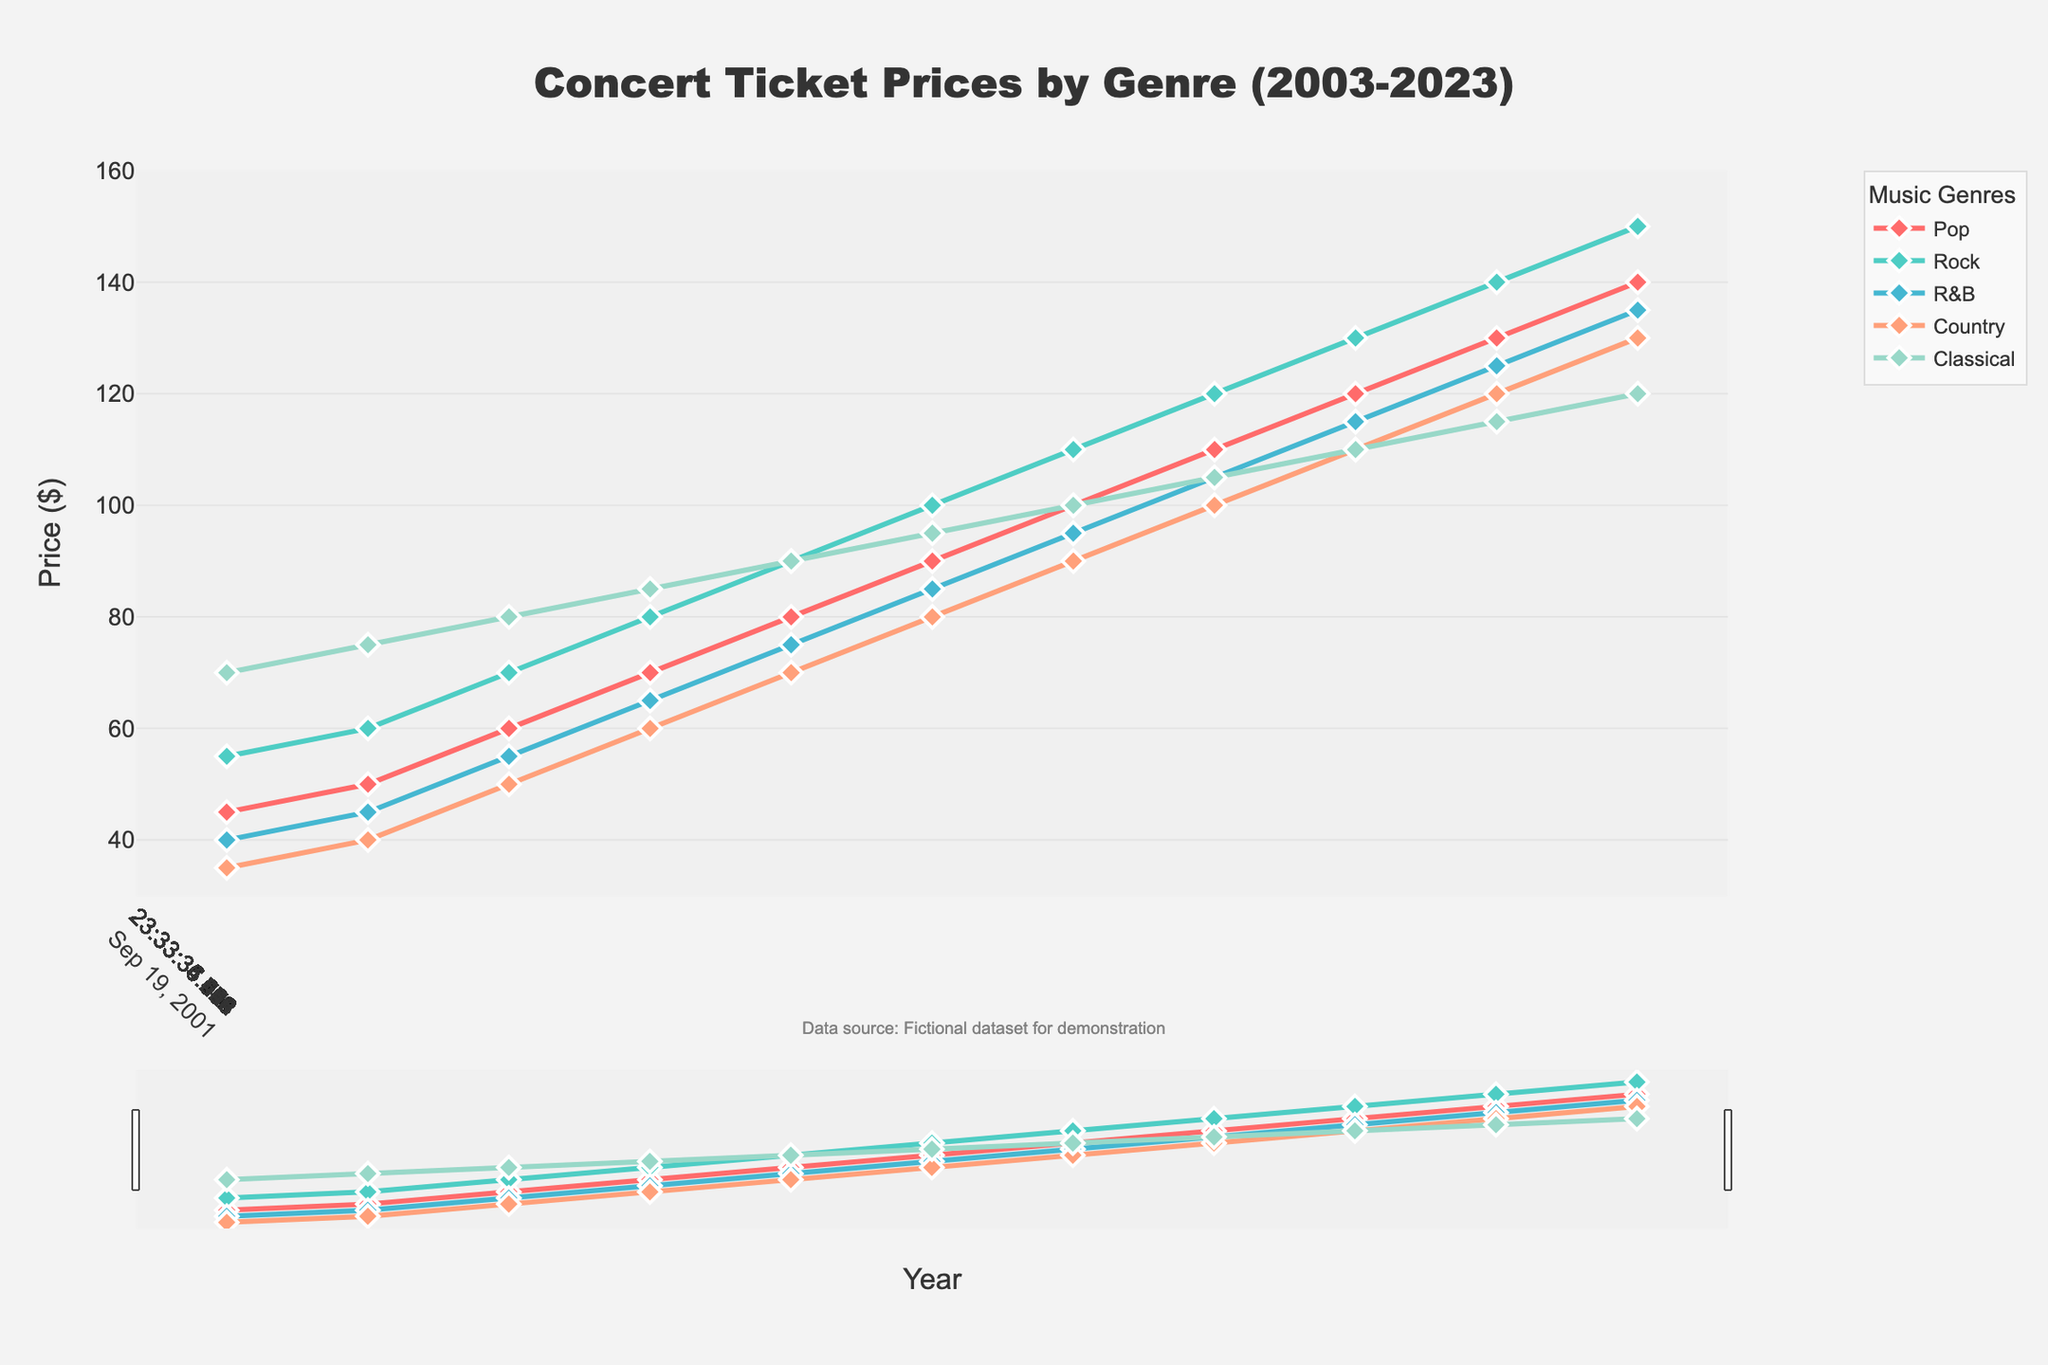Which music genre had the highest ticket price in 2003? The ticket prices for 2003 are: Pop: $45, Rock: $55, R&B: $40, Country: $35, and Classical: $70. The highest price is $70.
Answer: Classical In which year did Pop and Rock concert ticket prices both reach $100? From the figure, the year in which both Pop and Rock prices are at $100 is 2013.
Answer: 2013 What's the difference between the highest and lowest ticket prices for Classical music over these years? The highest price for Classical music is $120 (in 2023) and the lowest is $70 (in 2003). The difference is $120 - $70 = $50.
Answer: $50 How many years did it take for R&B ticket prices to increase from $40 to $135? R&B prices increased from $40 in 2003 to $135 in 2023. The duration is 2023 - 2003 = 20 years.
Answer: 20 years Which genre experienced the sharpest price increase between 2007 and 2009? Between 2007 and 2009: Pop increased by $10 (60 to 70), Rock increased by $10 (70 to 80), R&B increased by $10 (55 to 65), Country increased by $10 (50 to 60), and Classical increased by $5 (80 to 85). All pop, rock, R&B, and country experienced a $10 increase, which is the sharpest.
Answer: Pop, Rock, R&B, Country What's the average ticket price of Rock concerts over the last two decades? Summing the Rock ticket prices from 2003 to 2023: 55 + 60 + 70 + 80 + 90 + 100 + 110 + 120 + 130 + 140 + 150 = 1105. Number of years is 11. So, the average is 1105 / 11 = 100.45.
Answer: $100.45 Compare the ticket price trend of Country and Classical music between 2009 and 2023. Which genre showed a more consistent increase? From 2009 to 2023, Country increases by increments of $10 every two years: 2009: $60, 2011: $70, 2013: $80, 2015: $90, 2017: $100, 2019: $110, 2021: $120, 2023: $130. Classical shows consistent but smaller increments: 2009: $85, 2011: $90, 2013: $95, 2015: $100, 2017: $105, 2019: $110, 2021: $115, 2023: $120. Since both have consistent increases, Country has a more regular and larger step size.
Answer: Country By how much did Pop ticket prices exceed R&B ticket prices in 2021? In 2021, Pop ticket price is $130 and R&B ticket price is $125. The difference is $130 - $125 = $5.
Answer: $5 What's the total increase in ticket prices for Rock concerts from 2003 to 2023? In 2003, Rock ticket price was $55 and it increased to $150 in 2023. The total increase is $150 - $55 = $95.
Answer: $95 